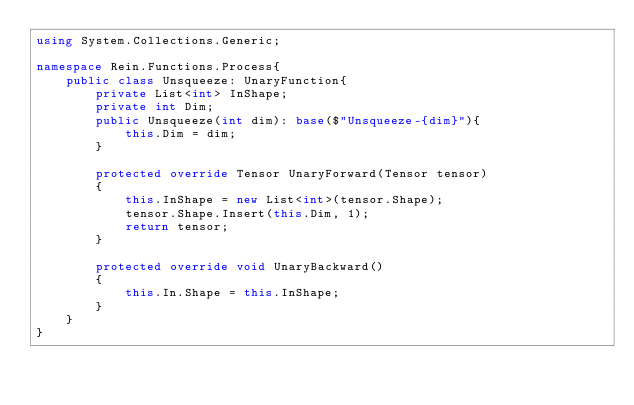<code> <loc_0><loc_0><loc_500><loc_500><_C#_>using System.Collections.Generic;

namespace Rein.Functions.Process{
    public class Unsqueeze: UnaryFunction{
        private List<int> InShape;
        private int Dim;
        public Unsqueeze(int dim): base($"Unsqueeze-{dim}"){
            this.Dim = dim;
        }

        protected override Tensor UnaryForward(Tensor tensor)
        {
            this.InShape = new List<int>(tensor.Shape);
            tensor.Shape.Insert(this.Dim, 1);
            return tensor;
        }

        protected override void UnaryBackward()
        {
            this.In.Shape = this.InShape;
        }
    }
}</code> 